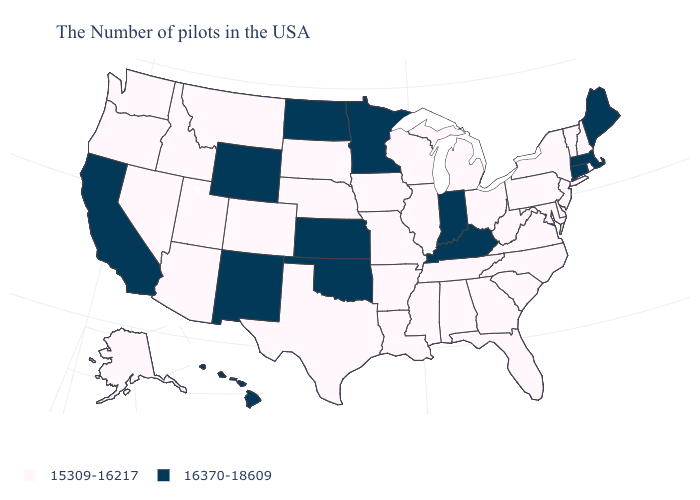What is the value of Ohio?
Answer briefly. 15309-16217. Does the map have missing data?
Be succinct. No. What is the highest value in the South ?
Write a very short answer. 16370-18609. Is the legend a continuous bar?
Short answer required. No. What is the value of Nebraska?
Keep it brief. 15309-16217. Name the states that have a value in the range 15309-16217?
Be succinct. Rhode Island, New Hampshire, Vermont, New York, New Jersey, Delaware, Maryland, Pennsylvania, Virginia, North Carolina, South Carolina, West Virginia, Ohio, Florida, Georgia, Michigan, Alabama, Tennessee, Wisconsin, Illinois, Mississippi, Louisiana, Missouri, Arkansas, Iowa, Nebraska, Texas, South Dakota, Colorado, Utah, Montana, Arizona, Idaho, Nevada, Washington, Oregon, Alaska. Among the states that border North Dakota , does Minnesota have the highest value?
Short answer required. Yes. Does the map have missing data?
Give a very brief answer. No. What is the value of Pennsylvania?
Write a very short answer. 15309-16217. Which states have the lowest value in the South?
Keep it brief. Delaware, Maryland, Virginia, North Carolina, South Carolina, West Virginia, Florida, Georgia, Alabama, Tennessee, Mississippi, Louisiana, Arkansas, Texas. Name the states that have a value in the range 15309-16217?
Quick response, please. Rhode Island, New Hampshire, Vermont, New York, New Jersey, Delaware, Maryland, Pennsylvania, Virginia, North Carolina, South Carolina, West Virginia, Ohio, Florida, Georgia, Michigan, Alabama, Tennessee, Wisconsin, Illinois, Mississippi, Louisiana, Missouri, Arkansas, Iowa, Nebraska, Texas, South Dakota, Colorado, Utah, Montana, Arizona, Idaho, Nevada, Washington, Oregon, Alaska. Does the map have missing data?
Be succinct. No. What is the value of Connecticut?
Answer briefly. 16370-18609. Does Maine have the highest value in the Northeast?
Be succinct. Yes. Among the states that border Oklahoma , does Arkansas have the highest value?
Write a very short answer. No. 